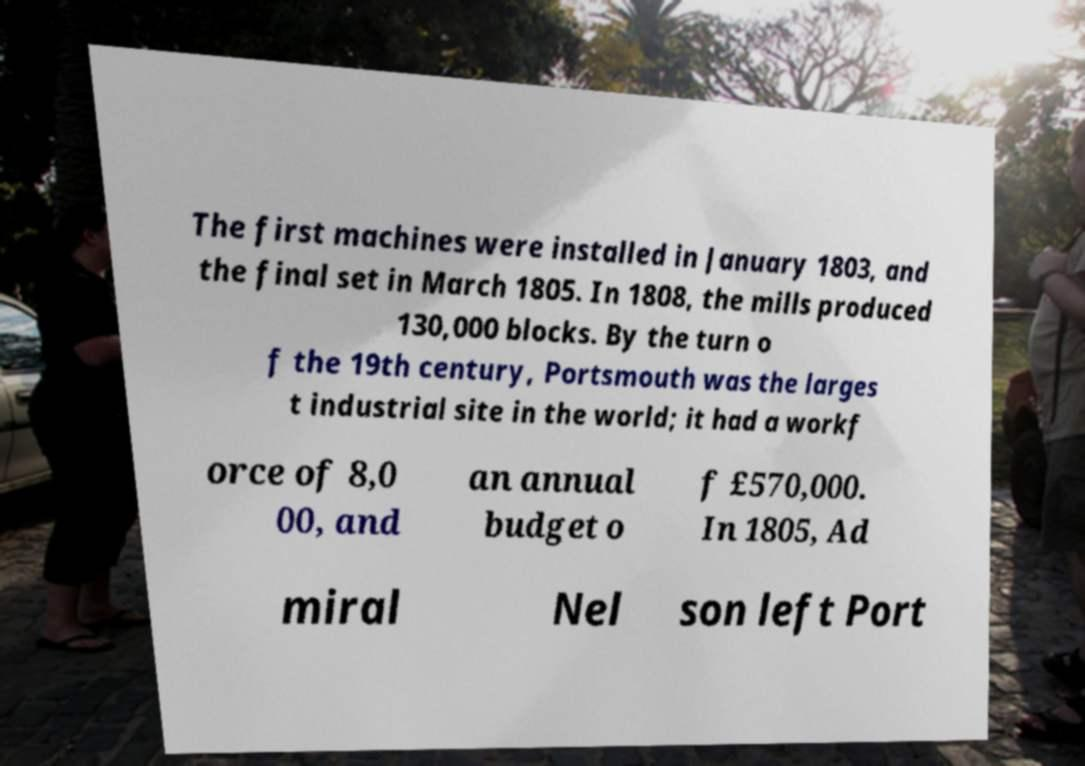Could you assist in decoding the text presented in this image and type it out clearly? The first machines were installed in January 1803, and the final set in March 1805. In 1808, the mills produced 130,000 blocks. By the turn o f the 19th century, Portsmouth was the larges t industrial site in the world; it had a workf orce of 8,0 00, and an annual budget o f £570,000. In 1805, Ad miral Nel son left Port 